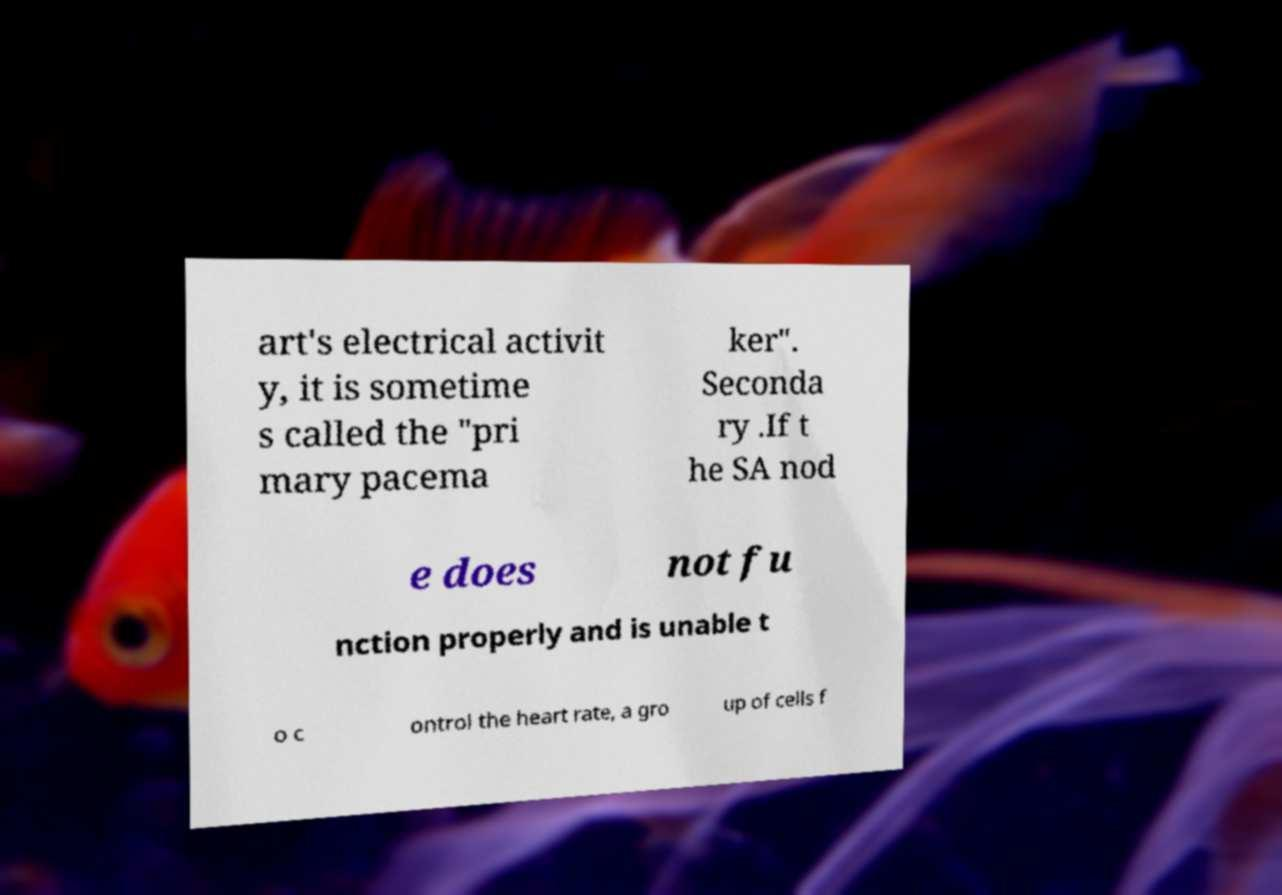Could you assist in decoding the text presented in this image and type it out clearly? art's electrical activit y, it is sometime s called the "pri mary pacema ker". Seconda ry .If t he SA nod e does not fu nction properly and is unable t o c ontrol the heart rate, a gro up of cells f 